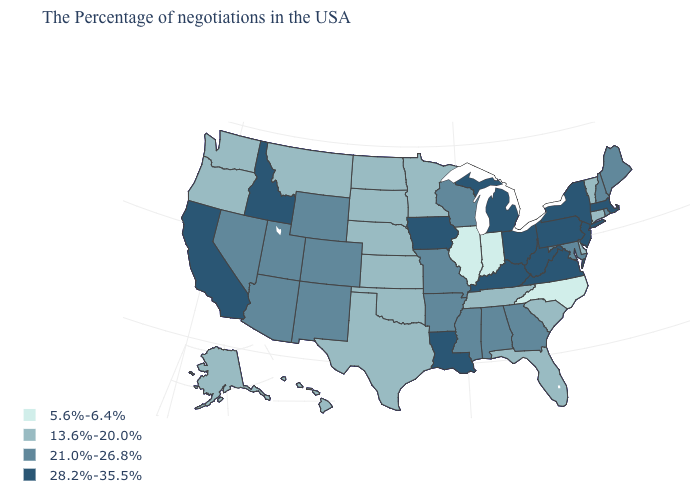Name the states that have a value in the range 13.6%-20.0%?
Be succinct. Vermont, Connecticut, Delaware, South Carolina, Florida, Tennessee, Minnesota, Kansas, Nebraska, Oklahoma, Texas, South Dakota, North Dakota, Montana, Washington, Oregon, Alaska, Hawaii. Is the legend a continuous bar?
Give a very brief answer. No. Among the states that border Louisiana , which have the highest value?
Answer briefly. Mississippi, Arkansas. Name the states that have a value in the range 5.6%-6.4%?
Short answer required. North Carolina, Indiana, Illinois. How many symbols are there in the legend?
Quick response, please. 4. Does Illinois have the lowest value in the MidWest?
Keep it brief. Yes. What is the value of South Dakota?
Answer briefly. 13.6%-20.0%. What is the highest value in the Northeast ?
Answer briefly. 28.2%-35.5%. Name the states that have a value in the range 5.6%-6.4%?
Short answer required. North Carolina, Indiana, Illinois. Name the states that have a value in the range 28.2%-35.5%?
Be succinct. Massachusetts, New York, New Jersey, Pennsylvania, Virginia, West Virginia, Ohio, Michigan, Kentucky, Louisiana, Iowa, Idaho, California. Does the first symbol in the legend represent the smallest category?
Be succinct. Yes. What is the lowest value in states that border Washington?
Concise answer only. 13.6%-20.0%. Does Montana have the lowest value in the West?
Concise answer only. Yes. Name the states that have a value in the range 5.6%-6.4%?
Concise answer only. North Carolina, Indiana, Illinois. Does New Jersey have the highest value in the USA?
Quick response, please. Yes. 